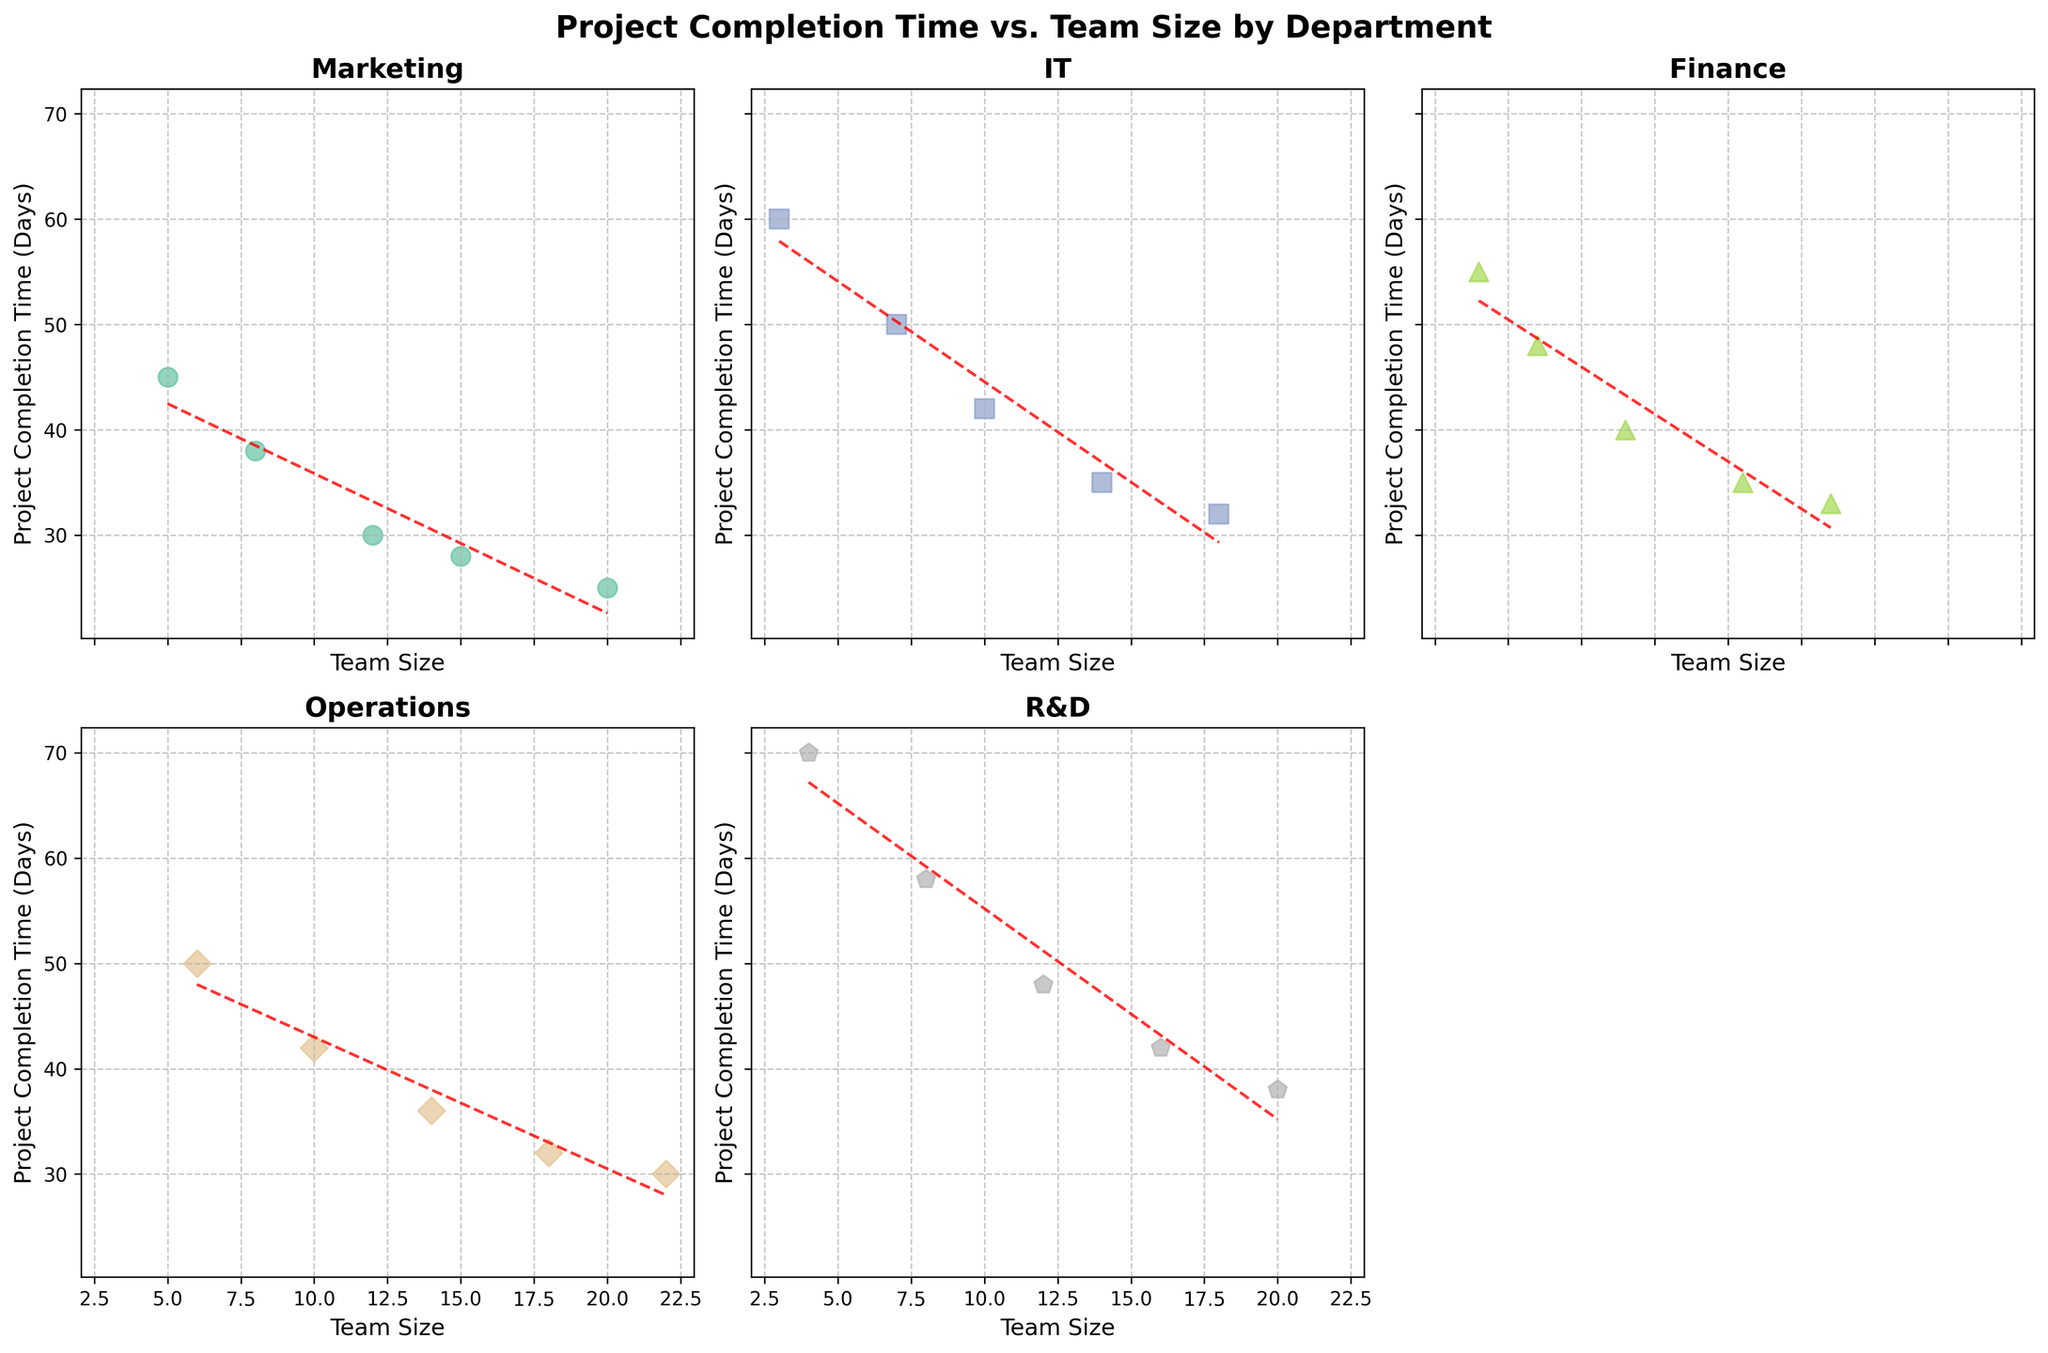How many unique departments are displayed in the figure? By observing the subplots, count the number of unique department titles given in each subplot.
Answer: 5 What is the relationship between team size and project completion time in the Marketing department? Look at the scatter plot for the Marketing department and observe the trendline. As team size increases, the project completion time decreases.
Answer: Decreasing Which department has the highest project completion time for the smallest team size? Check each subplot to find the data point representing the smallest team size. In the R&D subplot, the smallest team size is 4, with a project completion time of 70 days.
Answer: R&D How does the project completion time for IT compare to Finance for a team size of 10? Locate the data points in the IT and Finance subplots where the team size is 10. The project completion time for IT is 42 days, while for Finance, it is 40 days.
Answer: IT: 42 days, Finance: 40 days What is the general trend in project completion time as team size increases across all departments? Observe the trendlines in all subplots. In general, as team size increases, the project completion time tends to decrease for all departments.
Answer: Decreasing Which department shows the least variation in project completion time as team size changes? Look for the subplot with the trendline that is closest to a horizontal line, indicating less variation. The Operations department has a nearly horizontal trendline, indicating the least variation.
Answer: Operations In the Marketing department, how much does project completion time reduce when the team size increases from 5 to 20? Identify the project completion times for team sizes 5 (45 days) and 20 (25 days) in the Marketing subplot. The reduction is 45 - 25 = 20 days.
Answer: 20 days How does the average project completion time compare between Operations and R&D? Calculate the average project completion time for each department. Operations: (50 + 42 + 36 + 32 + 30)/5 = 38 days. R&D: (70 + 58 + 48 + 42 + 38)/5 = 51.2 days.
Answer: Operations: 38 days, R&D: 51.2 days Which department has the steepest trendline, indicating the most significant decrease in project completion time with increasing team size? Compare the slopes of the trendlines across subplots. The steepest trendline is for the R&D department, where time decreases most significantly.
Answer: R&D Which department has a team size data point represented by a pentagon marker? Observe the unique markers for each department in the respective subplots. The R&D department uses a pentagon marker.
Answer: R&D 